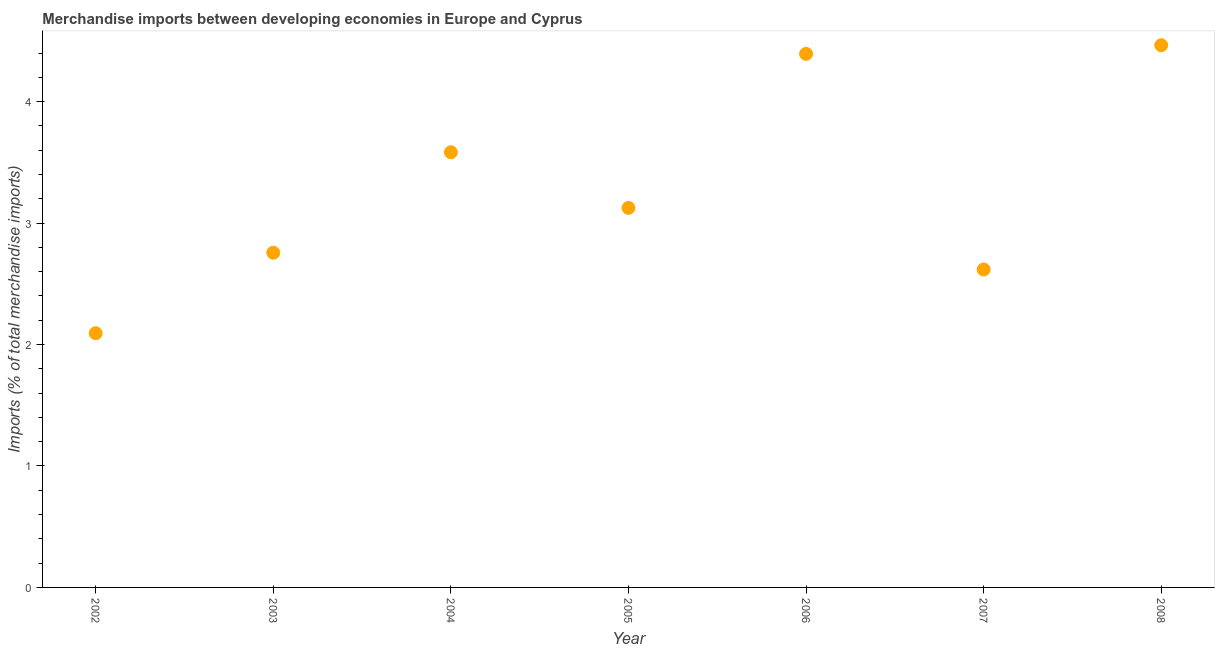What is the merchandise imports in 2005?
Keep it short and to the point. 3.12. Across all years, what is the maximum merchandise imports?
Provide a short and direct response. 4.46. Across all years, what is the minimum merchandise imports?
Your answer should be compact. 2.09. What is the sum of the merchandise imports?
Offer a very short reply. 23.03. What is the difference between the merchandise imports in 2003 and 2004?
Provide a succinct answer. -0.83. What is the average merchandise imports per year?
Keep it short and to the point. 3.29. What is the median merchandise imports?
Offer a terse response. 3.12. In how many years, is the merchandise imports greater than 3 %?
Offer a very short reply. 4. What is the ratio of the merchandise imports in 2007 to that in 2008?
Offer a terse response. 0.59. What is the difference between the highest and the second highest merchandise imports?
Offer a very short reply. 0.07. Is the sum of the merchandise imports in 2004 and 2007 greater than the maximum merchandise imports across all years?
Make the answer very short. Yes. What is the difference between the highest and the lowest merchandise imports?
Offer a very short reply. 2.37. Are the values on the major ticks of Y-axis written in scientific E-notation?
Make the answer very short. No. Does the graph contain any zero values?
Ensure brevity in your answer.  No. What is the title of the graph?
Offer a very short reply. Merchandise imports between developing economies in Europe and Cyprus. What is the label or title of the X-axis?
Give a very brief answer. Year. What is the label or title of the Y-axis?
Your response must be concise. Imports (% of total merchandise imports). What is the Imports (% of total merchandise imports) in 2002?
Offer a terse response. 2.09. What is the Imports (% of total merchandise imports) in 2003?
Offer a very short reply. 2.76. What is the Imports (% of total merchandise imports) in 2004?
Give a very brief answer. 3.58. What is the Imports (% of total merchandise imports) in 2005?
Ensure brevity in your answer.  3.12. What is the Imports (% of total merchandise imports) in 2006?
Offer a very short reply. 4.39. What is the Imports (% of total merchandise imports) in 2007?
Your answer should be very brief. 2.62. What is the Imports (% of total merchandise imports) in 2008?
Provide a succinct answer. 4.46. What is the difference between the Imports (% of total merchandise imports) in 2002 and 2003?
Provide a succinct answer. -0.66. What is the difference between the Imports (% of total merchandise imports) in 2002 and 2004?
Keep it short and to the point. -1.49. What is the difference between the Imports (% of total merchandise imports) in 2002 and 2005?
Keep it short and to the point. -1.03. What is the difference between the Imports (% of total merchandise imports) in 2002 and 2006?
Your answer should be compact. -2.3. What is the difference between the Imports (% of total merchandise imports) in 2002 and 2007?
Offer a very short reply. -0.52. What is the difference between the Imports (% of total merchandise imports) in 2002 and 2008?
Offer a terse response. -2.37. What is the difference between the Imports (% of total merchandise imports) in 2003 and 2004?
Ensure brevity in your answer.  -0.83. What is the difference between the Imports (% of total merchandise imports) in 2003 and 2005?
Your response must be concise. -0.37. What is the difference between the Imports (% of total merchandise imports) in 2003 and 2006?
Ensure brevity in your answer.  -1.64. What is the difference between the Imports (% of total merchandise imports) in 2003 and 2007?
Offer a very short reply. 0.14. What is the difference between the Imports (% of total merchandise imports) in 2003 and 2008?
Your answer should be compact. -1.71. What is the difference between the Imports (% of total merchandise imports) in 2004 and 2005?
Offer a terse response. 0.46. What is the difference between the Imports (% of total merchandise imports) in 2004 and 2006?
Provide a short and direct response. -0.81. What is the difference between the Imports (% of total merchandise imports) in 2004 and 2007?
Make the answer very short. 0.96. What is the difference between the Imports (% of total merchandise imports) in 2004 and 2008?
Provide a short and direct response. -0.88. What is the difference between the Imports (% of total merchandise imports) in 2005 and 2006?
Your response must be concise. -1.27. What is the difference between the Imports (% of total merchandise imports) in 2005 and 2007?
Provide a succinct answer. 0.51. What is the difference between the Imports (% of total merchandise imports) in 2005 and 2008?
Give a very brief answer. -1.34. What is the difference between the Imports (% of total merchandise imports) in 2006 and 2007?
Your answer should be compact. 1.78. What is the difference between the Imports (% of total merchandise imports) in 2006 and 2008?
Keep it short and to the point. -0.07. What is the difference between the Imports (% of total merchandise imports) in 2007 and 2008?
Ensure brevity in your answer.  -1.85. What is the ratio of the Imports (% of total merchandise imports) in 2002 to that in 2003?
Offer a terse response. 0.76. What is the ratio of the Imports (% of total merchandise imports) in 2002 to that in 2004?
Your response must be concise. 0.58. What is the ratio of the Imports (% of total merchandise imports) in 2002 to that in 2005?
Your response must be concise. 0.67. What is the ratio of the Imports (% of total merchandise imports) in 2002 to that in 2006?
Your answer should be compact. 0.48. What is the ratio of the Imports (% of total merchandise imports) in 2002 to that in 2007?
Your answer should be compact. 0.8. What is the ratio of the Imports (% of total merchandise imports) in 2002 to that in 2008?
Provide a succinct answer. 0.47. What is the ratio of the Imports (% of total merchandise imports) in 2003 to that in 2004?
Your answer should be very brief. 0.77. What is the ratio of the Imports (% of total merchandise imports) in 2003 to that in 2005?
Provide a short and direct response. 0.88. What is the ratio of the Imports (% of total merchandise imports) in 2003 to that in 2006?
Ensure brevity in your answer.  0.63. What is the ratio of the Imports (% of total merchandise imports) in 2003 to that in 2007?
Offer a very short reply. 1.05. What is the ratio of the Imports (% of total merchandise imports) in 2003 to that in 2008?
Keep it short and to the point. 0.62. What is the ratio of the Imports (% of total merchandise imports) in 2004 to that in 2005?
Your answer should be compact. 1.15. What is the ratio of the Imports (% of total merchandise imports) in 2004 to that in 2006?
Provide a succinct answer. 0.82. What is the ratio of the Imports (% of total merchandise imports) in 2004 to that in 2007?
Your answer should be very brief. 1.37. What is the ratio of the Imports (% of total merchandise imports) in 2004 to that in 2008?
Your response must be concise. 0.8. What is the ratio of the Imports (% of total merchandise imports) in 2005 to that in 2006?
Offer a very short reply. 0.71. What is the ratio of the Imports (% of total merchandise imports) in 2005 to that in 2007?
Provide a succinct answer. 1.19. What is the ratio of the Imports (% of total merchandise imports) in 2006 to that in 2007?
Give a very brief answer. 1.68. What is the ratio of the Imports (% of total merchandise imports) in 2006 to that in 2008?
Your response must be concise. 0.98. What is the ratio of the Imports (% of total merchandise imports) in 2007 to that in 2008?
Keep it short and to the point. 0.59. 